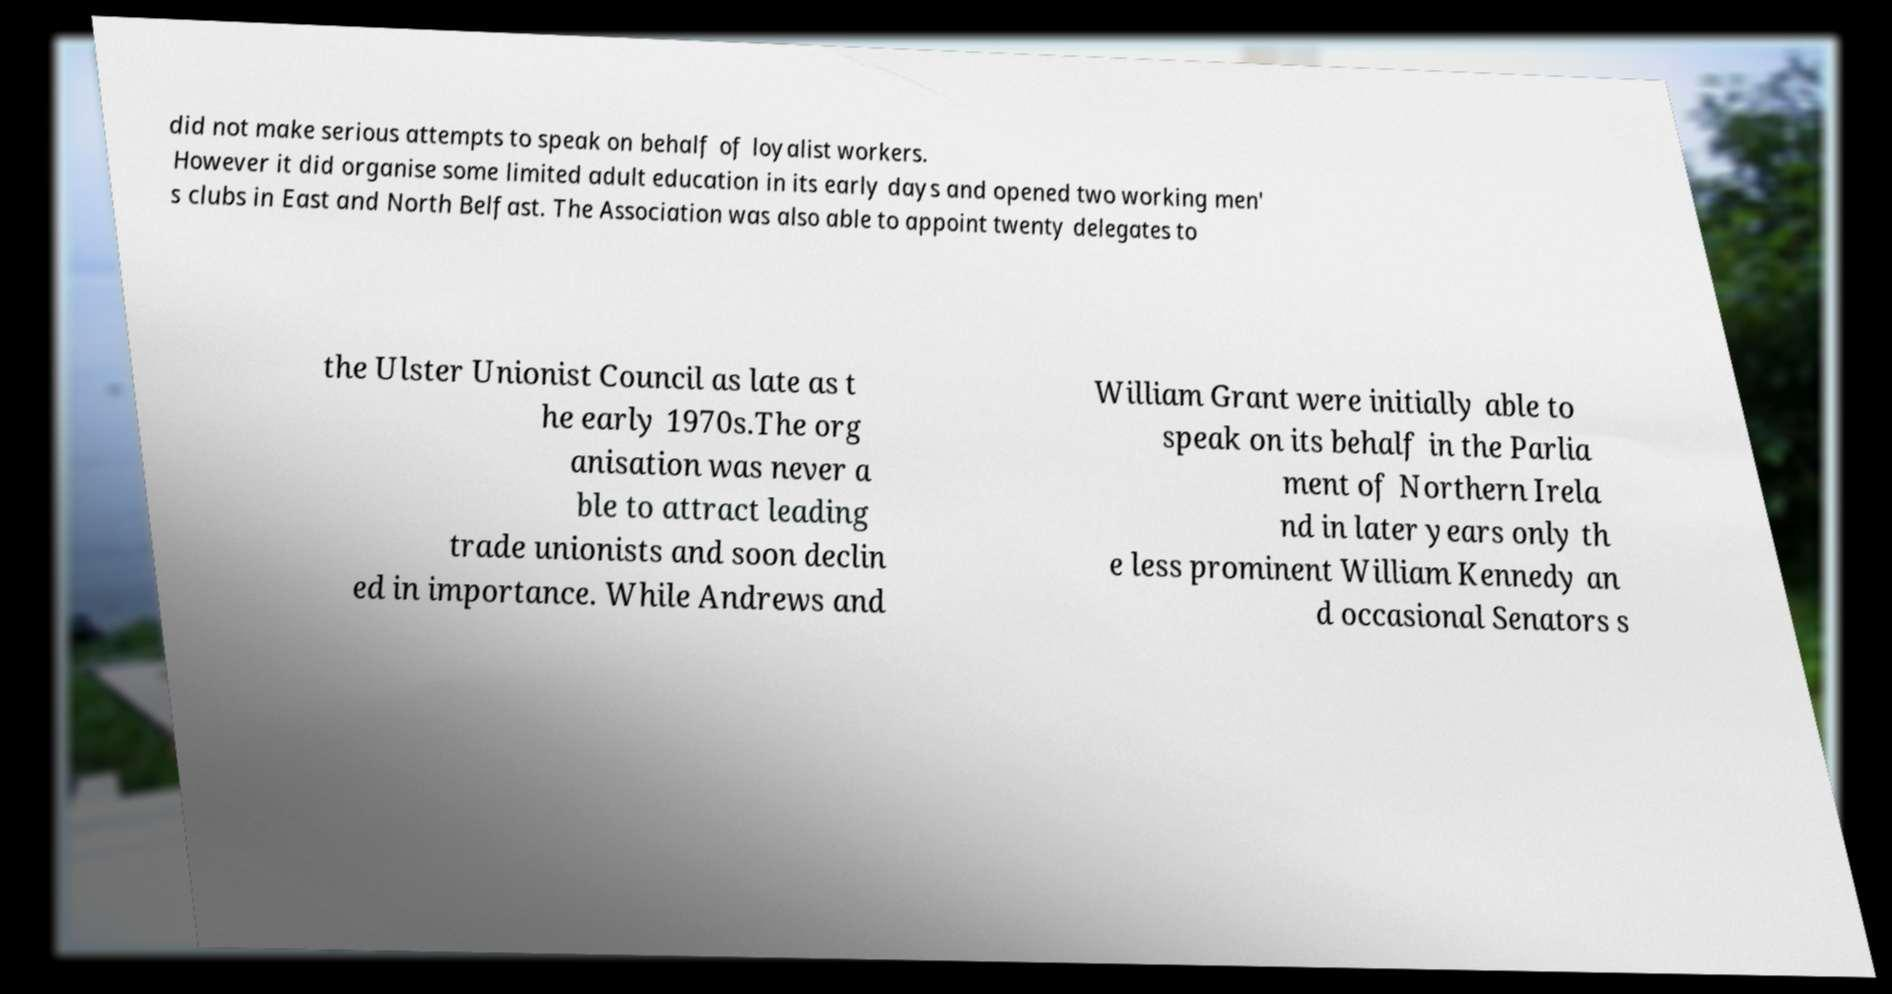There's text embedded in this image that I need extracted. Can you transcribe it verbatim? did not make serious attempts to speak on behalf of loyalist workers. However it did organise some limited adult education in its early days and opened two working men' s clubs in East and North Belfast. The Association was also able to appoint twenty delegates to the Ulster Unionist Council as late as t he early 1970s.The org anisation was never a ble to attract leading trade unionists and soon declin ed in importance. While Andrews and William Grant were initially able to speak on its behalf in the Parlia ment of Northern Irela nd in later years only th e less prominent William Kennedy an d occasional Senators s 